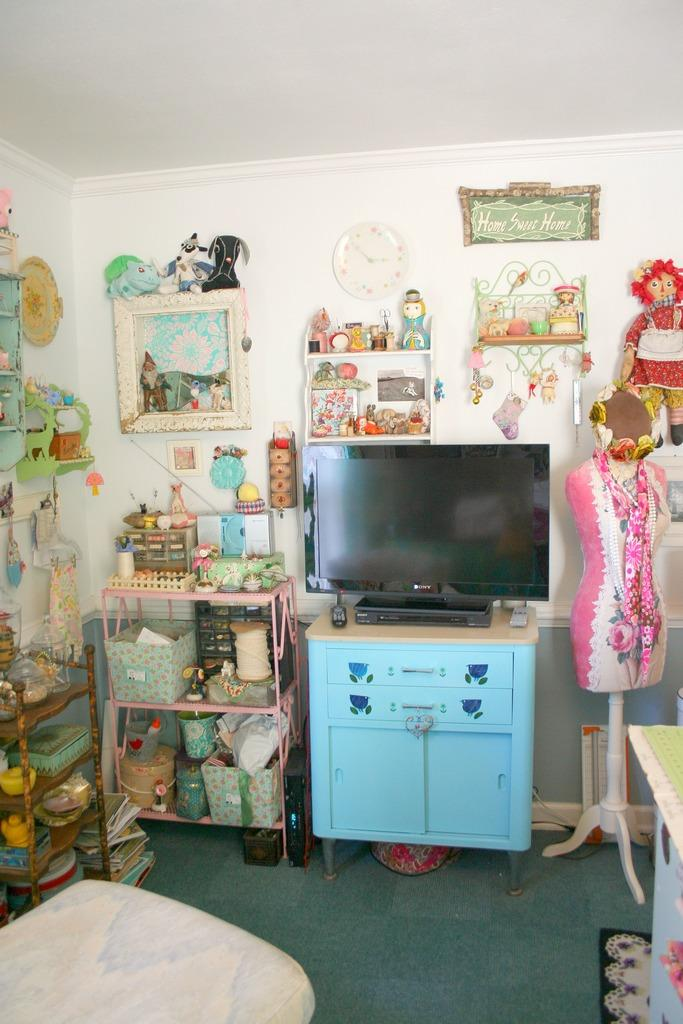Provide a one-sentence caption for the provided image. Room with a Sony television on top of a blue drawer. 